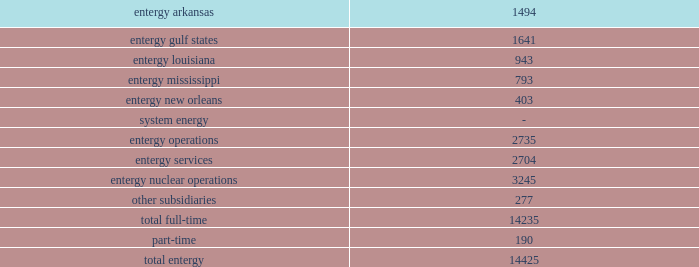Part i item 1 entergy corporation , domestic utility companies , and system energy employment litigation ( entergy corporation , entergy arkansas , entergy gulf states , entergy louisiana , entergy mississippi , entergy new orleans , and system energy ) entergy corporation and the domestic utility companies are defendants in numerous lawsuits that have been filed by former employees alleging that they were wrongfully terminated and/or discriminated against on the basis of age , race , sex , and/or other protected characteristics .
Entergy corporation and the domestic utility companies are vigorously defending these suits and deny any liability to the plaintiffs .
However , no assurance can be given as to the outcome of these cases , and at this time management cannot estimate the total amount of damages sought .
Included in the employment litigation are two cases filed in state court in claiborne county , mississippi in december 2002 .
The two cases were filed by former employees of entergy operations who were based at grand gulf .
Entergy operations and entergy employees are named as defendants .
The cases make employment-related claims , and seek in total $ 53 million in alleged actual damages and $ 168 million in punitive damages .
Entergy subsequently removed both proceedings to the federal district in jackson , mississippi .
Entergy cannot predict the ultimate outcome of this proceeding .
Research spending entergy is a member of the electric power research institute ( epri ) .
Epri conducts a broad range of research in major technical fields related to the electric utility industry .
Entergy participates in various epri projects based on entergy's needs and available resources .
The domestic utility companies contributed $ 1.6 million in 2004 , $ 1.5 million in 2003 , and $ 2.1 million in 2002 to epri .
The non-utility nuclear business contributed $ 3.2 million in 2004 and $ 3 million in both 2003 and 2002 to epri .
Employees employees are an integral part of entergy's commitment to serving its customers .
As of december 31 , 2004 , entergy employed 14425 people .
U.s .
Utility: .
Approximately 4900 employees are represented by the international brotherhood of electrical workers union , the utility workers union of america , and the international brotherhood of teamsters union. .
What percent of total full-time employees are in entergy gulf states ? 
Computations: (1641 / 14235)
Answer: 0.11528. 